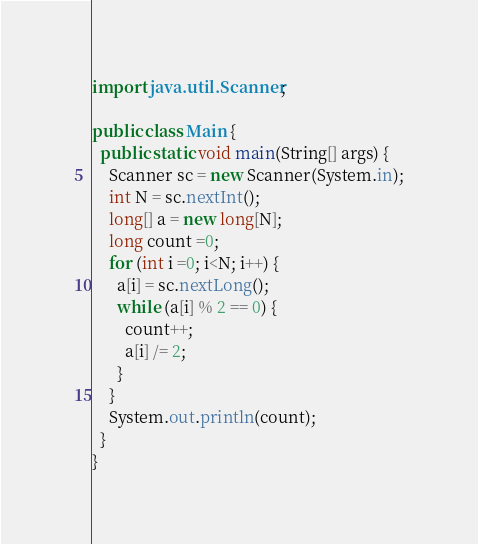Convert code to text. <code><loc_0><loc_0><loc_500><loc_500><_Java_>import java.util.Scanner;

public class Main { 
  public static void main(String[] args) {
    Scanner sc = new Scanner(System.in);
    int N = sc.nextInt();
    long[] a = new long[N];
    long count =0;
    for (int i =0; i<N; i++) {
      a[i] = sc.nextLong();
      while (a[i] % 2 == 0) {
        count++;
        a[i] /= 2;
      }
    }
    System.out.println(count);
  }
}</code> 